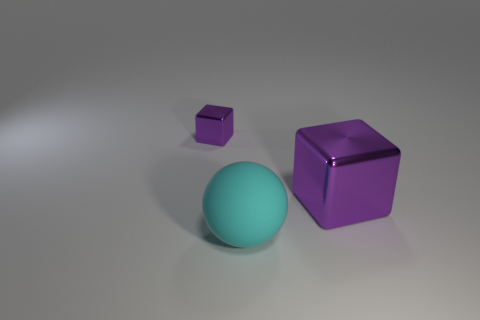What number of purple metallic things are on the left side of the big cyan thing and in front of the tiny purple shiny block?
Offer a terse response. 0. What number of other things are the same size as the rubber ball?
Ensure brevity in your answer.  1. Are there the same number of matte spheres that are behind the tiny purple metal block and metallic objects?
Keep it short and to the point. No. Does the shiny cube on the right side of the ball have the same color as the metal thing that is on the left side of the large matte sphere?
Provide a succinct answer. Yes. The thing that is both behind the large cyan rubber ball and on the left side of the large shiny object is made of what material?
Offer a terse response. Metal. What color is the tiny thing?
Your response must be concise. Purple. How many other things are the same shape as the big purple metallic object?
Ensure brevity in your answer.  1. Is the number of tiny purple metallic things to the left of the small cube the same as the number of purple blocks in front of the big shiny cube?
Make the answer very short. Yes. What material is the big purple thing?
Offer a terse response. Metal. There is a block that is on the right side of the small purple metal block; what is its material?
Provide a short and direct response. Metal. 